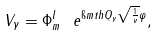Convert formula to latex. <formula><loc_0><loc_0><loc_500><loc_500>V _ { \gamma } = \Phi ^ { l } _ { m } \ e ^ { \i m t h Q _ { \gamma } \sqrt { \frac { 1 } { \nu } } \varphi } ,</formula> 